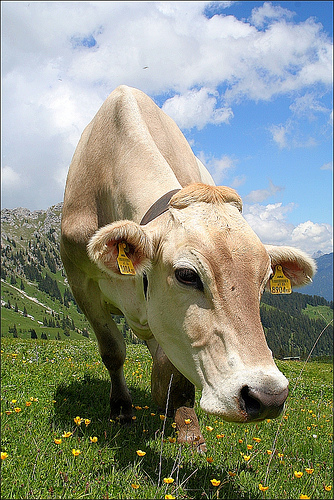Please transcribe the text information in this image. 8504 